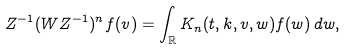<formula> <loc_0><loc_0><loc_500><loc_500>Z ^ { - 1 } ( W Z ^ { - 1 } ) ^ { n } f ( v ) = \int _ { \mathbb { R } } K _ { n } ( t , k , v , w ) f ( w ) \, d w ,</formula> 